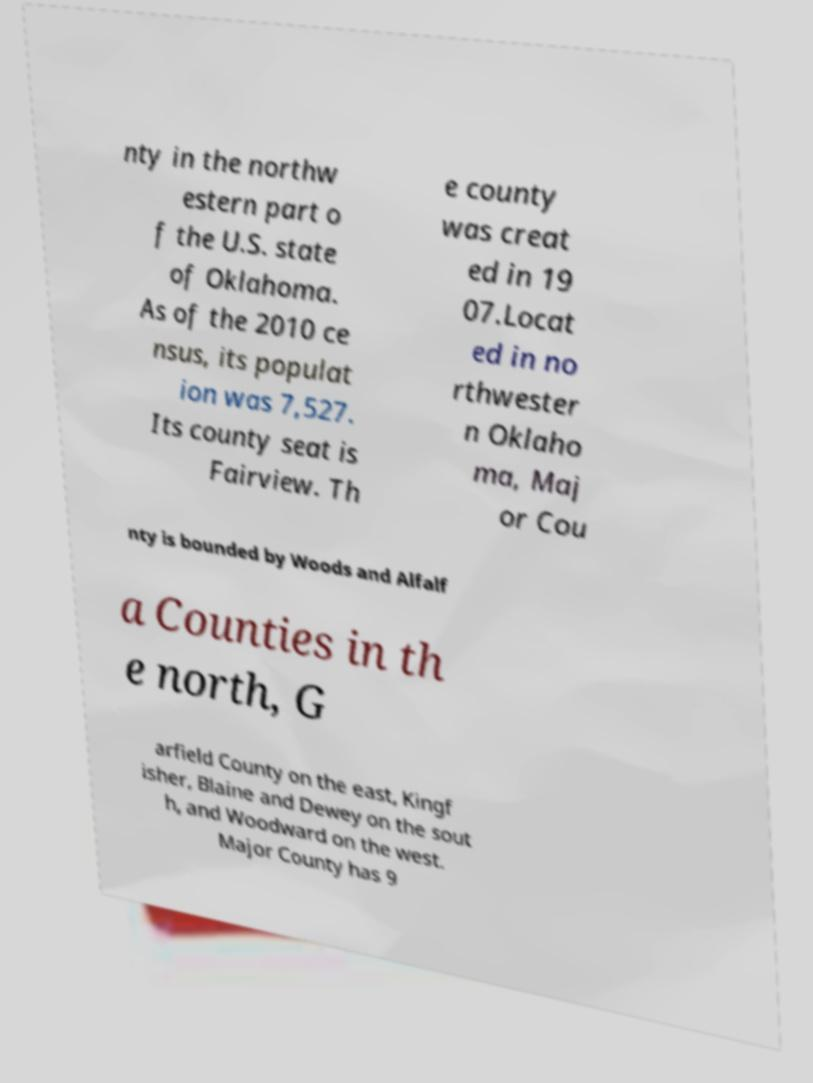For documentation purposes, I need the text within this image transcribed. Could you provide that? nty in the northw estern part o f the U.S. state of Oklahoma. As of the 2010 ce nsus, its populat ion was 7,527. Its county seat is Fairview. Th e county was creat ed in 19 07.Locat ed in no rthwester n Oklaho ma, Maj or Cou nty is bounded by Woods and Alfalf a Counties in th e north, G arfield County on the east, Kingf isher, Blaine and Dewey on the sout h, and Woodward on the west. Major County has 9 